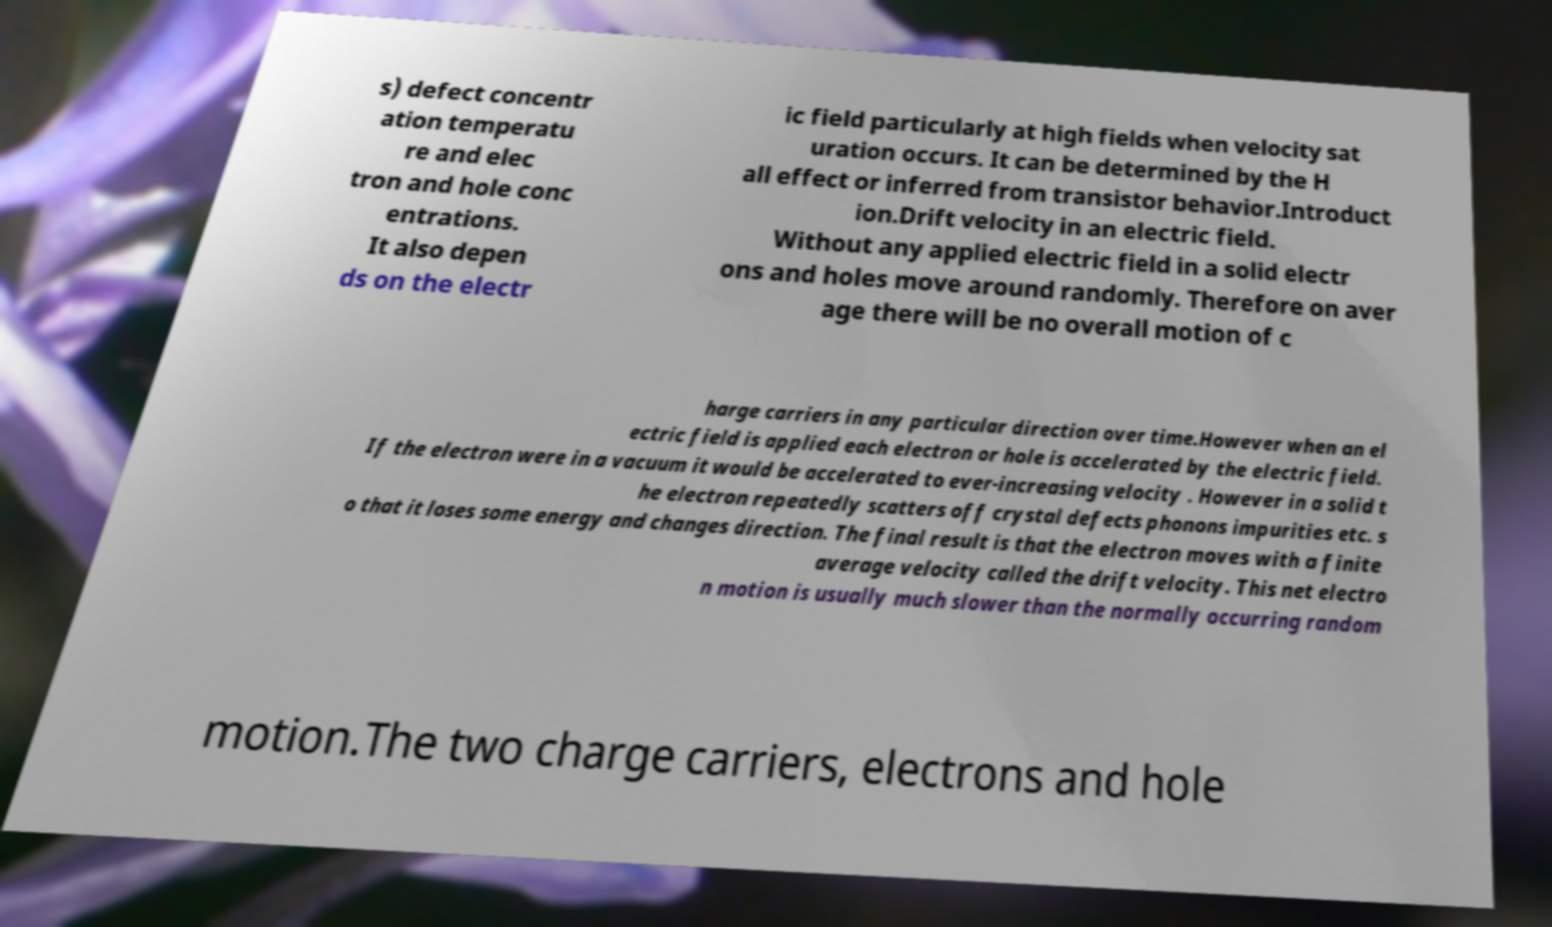Can you accurately transcribe the text from the provided image for me? s) defect concentr ation temperatu re and elec tron and hole conc entrations. It also depen ds on the electr ic field particularly at high fields when velocity sat uration occurs. It can be determined by the H all effect or inferred from transistor behavior.Introduct ion.Drift velocity in an electric field. Without any applied electric field in a solid electr ons and holes move around randomly. Therefore on aver age there will be no overall motion of c harge carriers in any particular direction over time.However when an el ectric field is applied each electron or hole is accelerated by the electric field. If the electron were in a vacuum it would be accelerated to ever-increasing velocity . However in a solid t he electron repeatedly scatters off crystal defects phonons impurities etc. s o that it loses some energy and changes direction. The final result is that the electron moves with a finite average velocity called the drift velocity. This net electro n motion is usually much slower than the normally occurring random motion.The two charge carriers, electrons and hole 